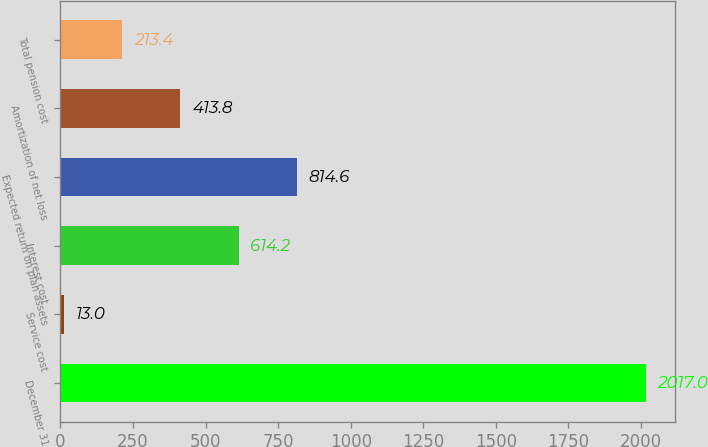Convert chart. <chart><loc_0><loc_0><loc_500><loc_500><bar_chart><fcel>December 31<fcel>Service cost<fcel>Interest cost<fcel>Expected return on plan assets<fcel>Amortization of net loss<fcel>Total pension cost<nl><fcel>2017<fcel>13<fcel>614.2<fcel>814.6<fcel>413.8<fcel>213.4<nl></chart> 